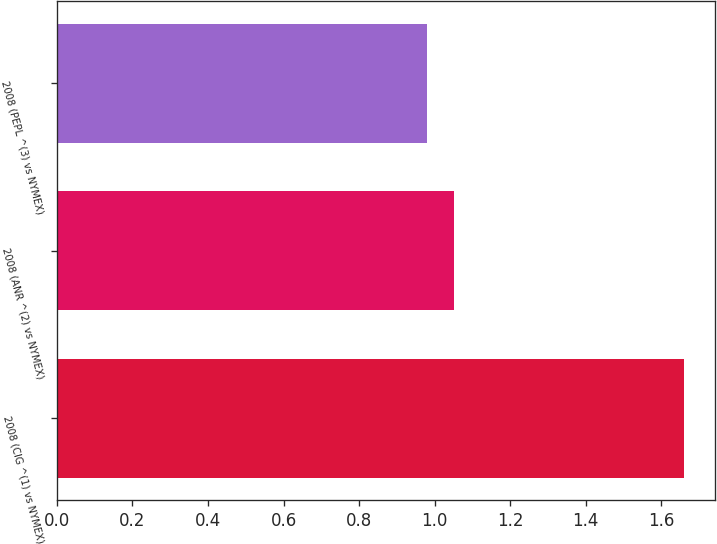<chart> <loc_0><loc_0><loc_500><loc_500><bar_chart><fcel>2008 (CIG ^(1) vs NYMEX)<fcel>2008 (ANR ^(2) vs NYMEX)<fcel>2008 (PEPL ^(3) vs NYMEX)<nl><fcel>1.66<fcel>1.05<fcel>0.98<nl></chart> 